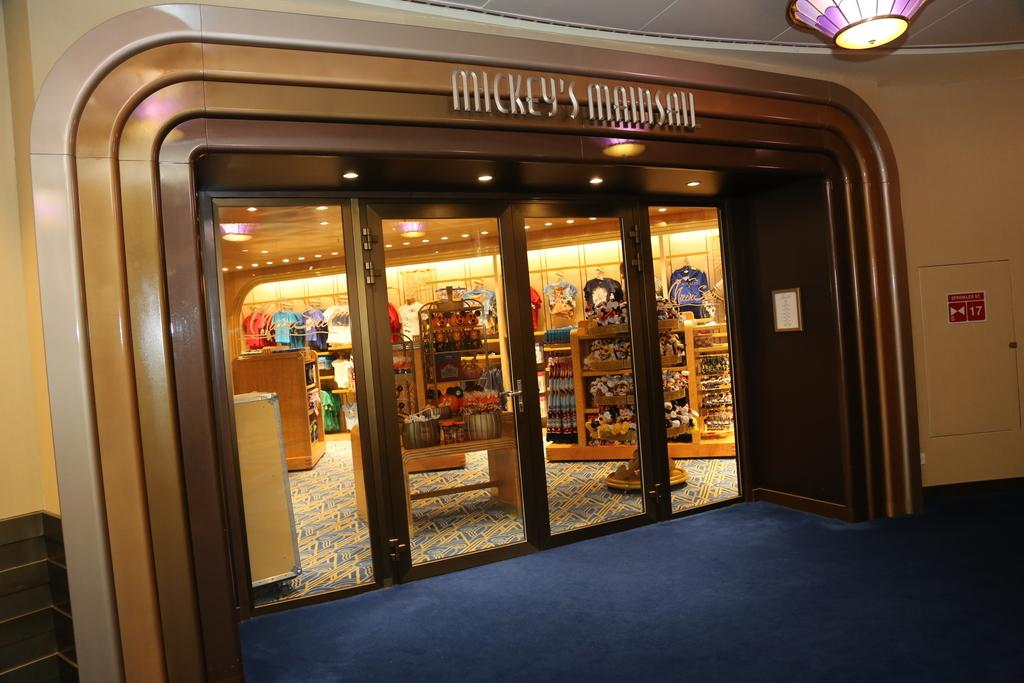Provide a one-sentence caption for the provided image. Looking into the store front of Mickeys Main Sail. 